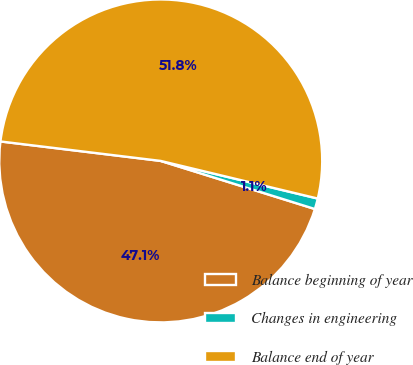Convert chart to OTSL. <chart><loc_0><loc_0><loc_500><loc_500><pie_chart><fcel>Balance beginning of year<fcel>Changes in engineering<fcel>Balance end of year<nl><fcel>47.11%<fcel>1.07%<fcel>51.82%<nl></chart> 